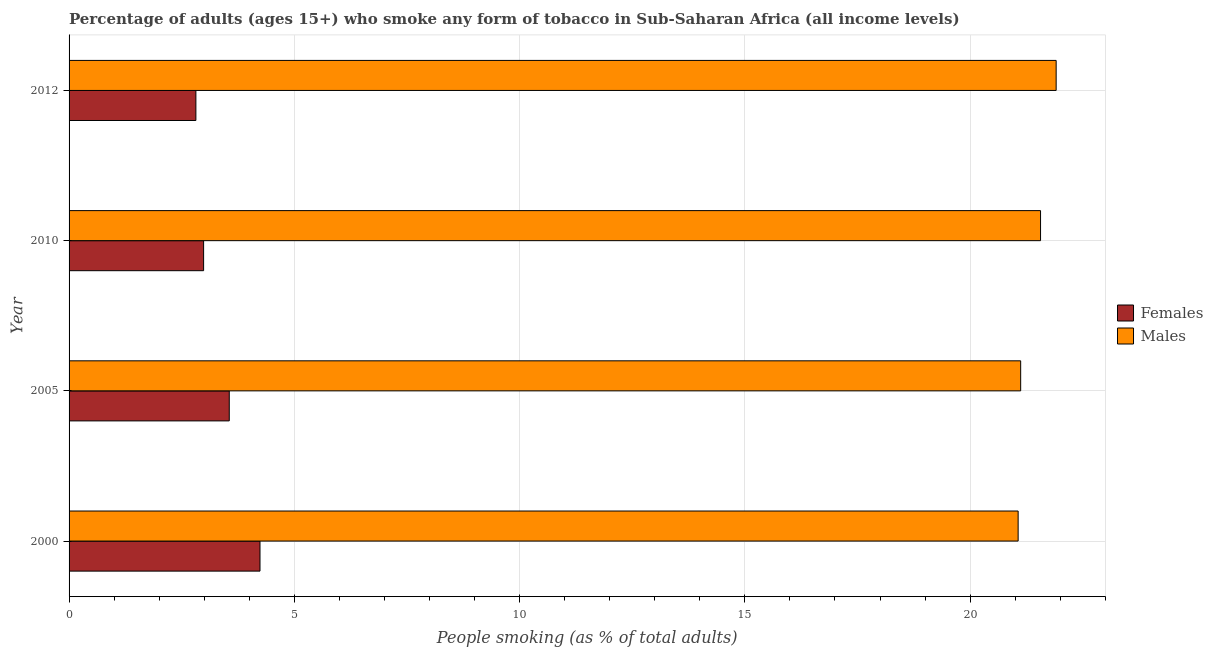How many groups of bars are there?
Your answer should be very brief. 4. Are the number of bars per tick equal to the number of legend labels?
Make the answer very short. Yes. Are the number of bars on each tick of the Y-axis equal?
Keep it short and to the point. Yes. How many bars are there on the 4th tick from the bottom?
Your answer should be compact. 2. In how many cases, is the number of bars for a given year not equal to the number of legend labels?
Provide a succinct answer. 0. What is the percentage of males who smoke in 2010?
Keep it short and to the point. 21.56. Across all years, what is the maximum percentage of females who smoke?
Offer a terse response. 4.24. Across all years, what is the minimum percentage of males who smoke?
Offer a very short reply. 21.07. In which year was the percentage of males who smoke maximum?
Your answer should be compact. 2012. In which year was the percentage of males who smoke minimum?
Offer a very short reply. 2000. What is the total percentage of females who smoke in the graph?
Your answer should be very brief. 13.59. What is the difference between the percentage of females who smoke in 2005 and that in 2012?
Ensure brevity in your answer.  0.74. What is the difference between the percentage of females who smoke in 2000 and the percentage of males who smoke in 2005?
Provide a short and direct response. -16.88. What is the average percentage of females who smoke per year?
Make the answer very short. 3.4. In the year 2012, what is the difference between the percentage of males who smoke and percentage of females who smoke?
Give a very brief answer. 19.09. What is the ratio of the percentage of males who smoke in 2010 to that in 2012?
Your response must be concise. 0.98. Is the percentage of females who smoke in 2000 less than that in 2012?
Offer a very short reply. No. What is the difference between the highest and the second highest percentage of females who smoke?
Offer a very short reply. 0.68. What is the difference between the highest and the lowest percentage of males who smoke?
Give a very brief answer. 0.84. In how many years, is the percentage of males who smoke greater than the average percentage of males who smoke taken over all years?
Provide a succinct answer. 2. What does the 1st bar from the top in 2010 represents?
Make the answer very short. Males. What does the 2nd bar from the bottom in 2010 represents?
Your answer should be compact. Males. Are all the bars in the graph horizontal?
Offer a very short reply. Yes. How many legend labels are there?
Provide a short and direct response. 2. How are the legend labels stacked?
Give a very brief answer. Vertical. What is the title of the graph?
Your response must be concise. Percentage of adults (ages 15+) who smoke any form of tobacco in Sub-Saharan Africa (all income levels). Does "Largest city" appear as one of the legend labels in the graph?
Give a very brief answer. No. What is the label or title of the X-axis?
Keep it short and to the point. People smoking (as % of total adults). What is the People smoking (as % of total adults) in Females in 2000?
Give a very brief answer. 4.24. What is the People smoking (as % of total adults) in Males in 2000?
Make the answer very short. 21.07. What is the People smoking (as % of total adults) of Females in 2005?
Provide a succinct answer. 3.56. What is the People smoking (as % of total adults) in Males in 2005?
Make the answer very short. 21.12. What is the People smoking (as % of total adults) of Females in 2010?
Your response must be concise. 2.99. What is the People smoking (as % of total adults) in Males in 2010?
Your response must be concise. 21.56. What is the People smoking (as % of total adults) in Females in 2012?
Offer a terse response. 2.81. What is the People smoking (as % of total adults) of Males in 2012?
Give a very brief answer. 21.91. Across all years, what is the maximum People smoking (as % of total adults) of Females?
Make the answer very short. 4.24. Across all years, what is the maximum People smoking (as % of total adults) in Males?
Your response must be concise. 21.91. Across all years, what is the minimum People smoking (as % of total adults) of Females?
Your answer should be very brief. 2.81. Across all years, what is the minimum People smoking (as % of total adults) of Males?
Offer a terse response. 21.07. What is the total People smoking (as % of total adults) of Females in the graph?
Provide a short and direct response. 13.59. What is the total People smoking (as % of total adults) in Males in the graph?
Provide a short and direct response. 85.66. What is the difference between the People smoking (as % of total adults) in Females in 2000 and that in 2005?
Ensure brevity in your answer.  0.68. What is the difference between the People smoking (as % of total adults) in Males in 2000 and that in 2005?
Give a very brief answer. -0.06. What is the difference between the People smoking (as % of total adults) of Females in 2000 and that in 2010?
Provide a short and direct response. 1.25. What is the difference between the People smoking (as % of total adults) of Males in 2000 and that in 2010?
Ensure brevity in your answer.  -0.5. What is the difference between the People smoking (as % of total adults) in Females in 2000 and that in 2012?
Make the answer very short. 1.42. What is the difference between the People smoking (as % of total adults) of Males in 2000 and that in 2012?
Your answer should be very brief. -0.84. What is the difference between the People smoking (as % of total adults) of Females in 2005 and that in 2010?
Make the answer very short. 0.57. What is the difference between the People smoking (as % of total adults) in Males in 2005 and that in 2010?
Provide a succinct answer. -0.44. What is the difference between the People smoking (as % of total adults) in Females in 2005 and that in 2012?
Your answer should be compact. 0.74. What is the difference between the People smoking (as % of total adults) in Males in 2005 and that in 2012?
Offer a very short reply. -0.79. What is the difference between the People smoking (as % of total adults) of Females in 2010 and that in 2012?
Your response must be concise. 0.17. What is the difference between the People smoking (as % of total adults) of Males in 2010 and that in 2012?
Ensure brevity in your answer.  -0.35. What is the difference between the People smoking (as % of total adults) in Females in 2000 and the People smoking (as % of total adults) in Males in 2005?
Offer a terse response. -16.88. What is the difference between the People smoking (as % of total adults) of Females in 2000 and the People smoking (as % of total adults) of Males in 2010?
Offer a terse response. -17.33. What is the difference between the People smoking (as % of total adults) of Females in 2000 and the People smoking (as % of total adults) of Males in 2012?
Offer a terse response. -17.67. What is the difference between the People smoking (as % of total adults) of Females in 2005 and the People smoking (as % of total adults) of Males in 2010?
Offer a terse response. -18.01. What is the difference between the People smoking (as % of total adults) in Females in 2005 and the People smoking (as % of total adults) in Males in 2012?
Offer a very short reply. -18.35. What is the difference between the People smoking (as % of total adults) in Females in 2010 and the People smoking (as % of total adults) in Males in 2012?
Ensure brevity in your answer.  -18.92. What is the average People smoking (as % of total adults) of Females per year?
Provide a short and direct response. 3.4. What is the average People smoking (as % of total adults) in Males per year?
Offer a very short reply. 21.42. In the year 2000, what is the difference between the People smoking (as % of total adults) in Females and People smoking (as % of total adults) in Males?
Give a very brief answer. -16.83. In the year 2005, what is the difference between the People smoking (as % of total adults) in Females and People smoking (as % of total adults) in Males?
Your answer should be very brief. -17.57. In the year 2010, what is the difference between the People smoking (as % of total adults) in Females and People smoking (as % of total adults) in Males?
Your answer should be compact. -18.58. In the year 2012, what is the difference between the People smoking (as % of total adults) in Females and People smoking (as % of total adults) in Males?
Provide a succinct answer. -19.1. What is the ratio of the People smoking (as % of total adults) in Females in 2000 to that in 2005?
Ensure brevity in your answer.  1.19. What is the ratio of the People smoking (as % of total adults) in Males in 2000 to that in 2005?
Keep it short and to the point. 1. What is the ratio of the People smoking (as % of total adults) of Females in 2000 to that in 2010?
Your answer should be compact. 1.42. What is the ratio of the People smoking (as % of total adults) of Males in 2000 to that in 2010?
Make the answer very short. 0.98. What is the ratio of the People smoking (as % of total adults) of Females in 2000 to that in 2012?
Provide a succinct answer. 1.51. What is the ratio of the People smoking (as % of total adults) in Males in 2000 to that in 2012?
Give a very brief answer. 0.96. What is the ratio of the People smoking (as % of total adults) of Females in 2005 to that in 2010?
Your answer should be compact. 1.19. What is the ratio of the People smoking (as % of total adults) of Males in 2005 to that in 2010?
Your answer should be very brief. 0.98. What is the ratio of the People smoking (as % of total adults) of Females in 2005 to that in 2012?
Keep it short and to the point. 1.26. What is the ratio of the People smoking (as % of total adults) in Males in 2005 to that in 2012?
Your answer should be very brief. 0.96. What is the ratio of the People smoking (as % of total adults) of Females in 2010 to that in 2012?
Your answer should be compact. 1.06. What is the ratio of the People smoking (as % of total adults) in Males in 2010 to that in 2012?
Your answer should be very brief. 0.98. What is the difference between the highest and the second highest People smoking (as % of total adults) of Females?
Your response must be concise. 0.68. What is the difference between the highest and the second highest People smoking (as % of total adults) of Males?
Make the answer very short. 0.35. What is the difference between the highest and the lowest People smoking (as % of total adults) in Females?
Keep it short and to the point. 1.42. What is the difference between the highest and the lowest People smoking (as % of total adults) in Males?
Give a very brief answer. 0.84. 